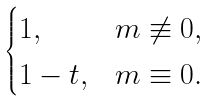<formula> <loc_0><loc_0><loc_500><loc_500>\begin{cases} 1 , & m \not \equiv 0 , \\ 1 - t , & m \equiv 0 . \end{cases}</formula> 